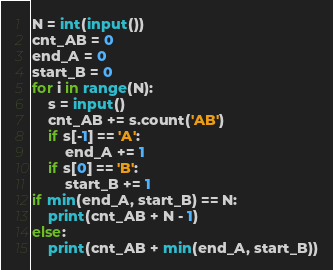Convert code to text. <code><loc_0><loc_0><loc_500><loc_500><_Python_>N = int(input())
cnt_AB = 0
end_A = 0
start_B = 0
for i in range(N):
    s = input()
    cnt_AB += s.count('AB')
    if s[-1] == 'A':
        end_A += 1
    if s[0] == 'B':
        start_B += 1
if min(end_A, start_B) == N:
    print(cnt_AB + N - 1)
else:
    print(cnt_AB + min(end_A, start_B))</code> 